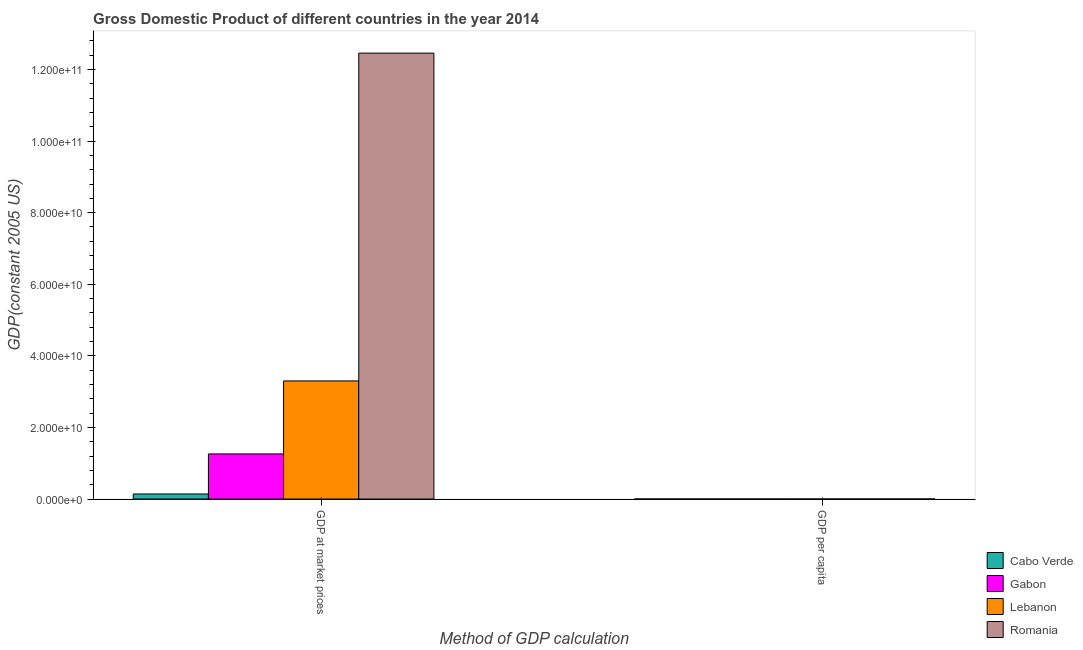How many groups of bars are there?
Provide a succinct answer. 2. Are the number of bars per tick equal to the number of legend labels?
Give a very brief answer. Yes. How many bars are there on the 1st tick from the left?
Make the answer very short. 4. What is the label of the 2nd group of bars from the left?
Provide a succinct answer. GDP per capita. What is the gdp at market prices in Romania?
Your response must be concise. 1.25e+11. Across all countries, what is the maximum gdp at market prices?
Provide a succinct answer. 1.25e+11. Across all countries, what is the minimum gdp at market prices?
Your answer should be compact. 1.41e+09. In which country was the gdp at market prices maximum?
Your response must be concise. Romania. In which country was the gdp per capita minimum?
Keep it short and to the point. Cabo Verde. What is the total gdp at market prices in the graph?
Offer a very short reply. 1.72e+11. What is the difference between the gdp at market prices in Gabon and that in Lebanon?
Your response must be concise. -2.04e+1. What is the difference between the gdp per capita in Lebanon and the gdp at market prices in Cabo Verde?
Ensure brevity in your answer.  -1.41e+09. What is the average gdp at market prices per country?
Provide a succinct answer. 4.29e+1. What is the difference between the gdp at market prices and gdp per capita in Lebanon?
Make the answer very short. 3.30e+1. In how many countries, is the gdp per capita greater than 84000000000 US$?
Provide a succinct answer. 0. What is the ratio of the gdp per capita in Romania to that in Lebanon?
Provide a short and direct response. 0.86. In how many countries, is the gdp at market prices greater than the average gdp at market prices taken over all countries?
Your answer should be compact. 1. What does the 1st bar from the left in GDP at market prices represents?
Ensure brevity in your answer.  Cabo Verde. What does the 2nd bar from the right in GDP at market prices represents?
Your answer should be compact. Lebanon. Are all the bars in the graph horizontal?
Offer a very short reply. No. What is the title of the graph?
Make the answer very short. Gross Domestic Product of different countries in the year 2014. Does "Germany" appear as one of the legend labels in the graph?
Make the answer very short. No. What is the label or title of the X-axis?
Provide a succinct answer. Method of GDP calculation. What is the label or title of the Y-axis?
Offer a very short reply. GDP(constant 2005 US). What is the GDP(constant 2005 US) in Cabo Verde in GDP at market prices?
Make the answer very short. 1.41e+09. What is the GDP(constant 2005 US) of Gabon in GDP at market prices?
Offer a very short reply. 1.26e+1. What is the GDP(constant 2005 US) of Lebanon in GDP at market prices?
Your response must be concise. 3.30e+1. What is the GDP(constant 2005 US) in Romania in GDP at market prices?
Keep it short and to the point. 1.25e+11. What is the GDP(constant 2005 US) in Cabo Verde in GDP per capita?
Keep it short and to the point. 2743.42. What is the GDP(constant 2005 US) in Gabon in GDP per capita?
Your response must be concise. 7469.58. What is the GDP(constant 2005 US) of Lebanon in GDP per capita?
Your answer should be very brief. 7256.51. What is the GDP(constant 2005 US) of Romania in GDP per capita?
Make the answer very short. 6256.51. Across all Method of GDP calculation, what is the maximum GDP(constant 2005 US) of Cabo Verde?
Provide a succinct answer. 1.41e+09. Across all Method of GDP calculation, what is the maximum GDP(constant 2005 US) in Gabon?
Ensure brevity in your answer.  1.26e+1. Across all Method of GDP calculation, what is the maximum GDP(constant 2005 US) of Lebanon?
Your answer should be very brief. 3.30e+1. Across all Method of GDP calculation, what is the maximum GDP(constant 2005 US) in Romania?
Offer a very short reply. 1.25e+11. Across all Method of GDP calculation, what is the minimum GDP(constant 2005 US) of Cabo Verde?
Offer a terse response. 2743.42. Across all Method of GDP calculation, what is the minimum GDP(constant 2005 US) in Gabon?
Give a very brief answer. 7469.58. Across all Method of GDP calculation, what is the minimum GDP(constant 2005 US) in Lebanon?
Your answer should be very brief. 7256.51. Across all Method of GDP calculation, what is the minimum GDP(constant 2005 US) in Romania?
Your answer should be compact. 6256.51. What is the total GDP(constant 2005 US) of Cabo Verde in the graph?
Provide a succinct answer. 1.41e+09. What is the total GDP(constant 2005 US) in Gabon in the graph?
Keep it short and to the point. 1.26e+1. What is the total GDP(constant 2005 US) of Lebanon in the graph?
Make the answer very short. 3.30e+1. What is the total GDP(constant 2005 US) of Romania in the graph?
Provide a succinct answer. 1.25e+11. What is the difference between the GDP(constant 2005 US) in Cabo Verde in GDP at market prices and that in GDP per capita?
Ensure brevity in your answer.  1.41e+09. What is the difference between the GDP(constant 2005 US) of Gabon in GDP at market prices and that in GDP per capita?
Your answer should be compact. 1.26e+1. What is the difference between the GDP(constant 2005 US) in Lebanon in GDP at market prices and that in GDP per capita?
Offer a terse response. 3.30e+1. What is the difference between the GDP(constant 2005 US) of Romania in GDP at market prices and that in GDP per capita?
Your answer should be very brief. 1.25e+11. What is the difference between the GDP(constant 2005 US) of Cabo Verde in GDP at market prices and the GDP(constant 2005 US) of Gabon in GDP per capita?
Provide a short and direct response. 1.41e+09. What is the difference between the GDP(constant 2005 US) in Cabo Verde in GDP at market prices and the GDP(constant 2005 US) in Lebanon in GDP per capita?
Your answer should be very brief. 1.41e+09. What is the difference between the GDP(constant 2005 US) in Cabo Verde in GDP at market prices and the GDP(constant 2005 US) in Romania in GDP per capita?
Your answer should be compact. 1.41e+09. What is the difference between the GDP(constant 2005 US) of Gabon in GDP at market prices and the GDP(constant 2005 US) of Lebanon in GDP per capita?
Provide a succinct answer. 1.26e+1. What is the difference between the GDP(constant 2005 US) of Gabon in GDP at market prices and the GDP(constant 2005 US) of Romania in GDP per capita?
Keep it short and to the point. 1.26e+1. What is the difference between the GDP(constant 2005 US) in Lebanon in GDP at market prices and the GDP(constant 2005 US) in Romania in GDP per capita?
Your answer should be compact. 3.30e+1. What is the average GDP(constant 2005 US) in Cabo Verde per Method of GDP calculation?
Offer a terse response. 7.05e+08. What is the average GDP(constant 2005 US) in Gabon per Method of GDP calculation?
Your response must be concise. 6.30e+09. What is the average GDP(constant 2005 US) of Lebanon per Method of GDP calculation?
Your answer should be compact. 1.65e+1. What is the average GDP(constant 2005 US) of Romania per Method of GDP calculation?
Make the answer very short. 6.23e+1. What is the difference between the GDP(constant 2005 US) in Cabo Verde and GDP(constant 2005 US) in Gabon in GDP at market prices?
Provide a succinct answer. -1.12e+1. What is the difference between the GDP(constant 2005 US) of Cabo Verde and GDP(constant 2005 US) of Lebanon in GDP at market prices?
Your answer should be very brief. -3.16e+1. What is the difference between the GDP(constant 2005 US) of Cabo Verde and GDP(constant 2005 US) of Romania in GDP at market prices?
Keep it short and to the point. -1.23e+11. What is the difference between the GDP(constant 2005 US) in Gabon and GDP(constant 2005 US) in Lebanon in GDP at market prices?
Make the answer very short. -2.04e+1. What is the difference between the GDP(constant 2005 US) in Gabon and GDP(constant 2005 US) in Romania in GDP at market prices?
Offer a terse response. -1.12e+11. What is the difference between the GDP(constant 2005 US) of Lebanon and GDP(constant 2005 US) of Romania in GDP at market prices?
Your answer should be very brief. -9.16e+1. What is the difference between the GDP(constant 2005 US) of Cabo Verde and GDP(constant 2005 US) of Gabon in GDP per capita?
Your answer should be very brief. -4726.16. What is the difference between the GDP(constant 2005 US) in Cabo Verde and GDP(constant 2005 US) in Lebanon in GDP per capita?
Ensure brevity in your answer.  -4513.09. What is the difference between the GDP(constant 2005 US) of Cabo Verde and GDP(constant 2005 US) of Romania in GDP per capita?
Ensure brevity in your answer.  -3513.09. What is the difference between the GDP(constant 2005 US) in Gabon and GDP(constant 2005 US) in Lebanon in GDP per capita?
Keep it short and to the point. 213.07. What is the difference between the GDP(constant 2005 US) in Gabon and GDP(constant 2005 US) in Romania in GDP per capita?
Your response must be concise. 1213.07. What is the difference between the GDP(constant 2005 US) of Lebanon and GDP(constant 2005 US) of Romania in GDP per capita?
Offer a very short reply. 1000. What is the ratio of the GDP(constant 2005 US) of Cabo Verde in GDP at market prices to that in GDP per capita?
Keep it short and to the point. 5.14e+05. What is the ratio of the GDP(constant 2005 US) in Gabon in GDP at market prices to that in GDP per capita?
Provide a succinct answer. 1.69e+06. What is the ratio of the GDP(constant 2005 US) in Lebanon in GDP at market prices to that in GDP per capita?
Your answer should be compact. 4.55e+06. What is the ratio of the GDP(constant 2005 US) in Romania in GDP at market prices to that in GDP per capita?
Make the answer very short. 1.99e+07. What is the difference between the highest and the second highest GDP(constant 2005 US) in Cabo Verde?
Your answer should be very brief. 1.41e+09. What is the difference between the highest and the second highest GDP(constant 2005 US) in Gabon?
Provide a short and direct response. 1.26e+1. What is the difference between the highest and the second highest GDP(constant 2005 US) of Lebanon?
Keep it short and to the point. 3.30e+1. What is the difference between the highest and the second highest GDP(constant 2005 US) of Romania?
Your response must be concise. 1.25e+11. What is the difference between the highest and the lowest GDP(constant 2005 US) of Cabo Verde?
Your answer should be compact. 1.41e+09. What is the difference between the highest and the lowest GDP(constant 2005 US) in Gabon?
Provide a short and direct response. 1.26e+1. What is the difference between the highest and the lowest GDP(constant 2005 US) in Lebanon?
Keep it short and to the point. 3.30e+1. What is the difference between the highest and the lowest GDP(constant 2005 US) of Romania?
Provide a short and direct response. 1.25e+11. 